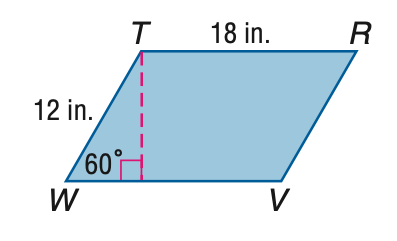Answer the mathemtical geometry problem and directly provide the correct option letter.
Question: Find the perimeter of \parallelogram T R V W.
Choices: A: 30 B: 48 C: 60 D: 72 C 